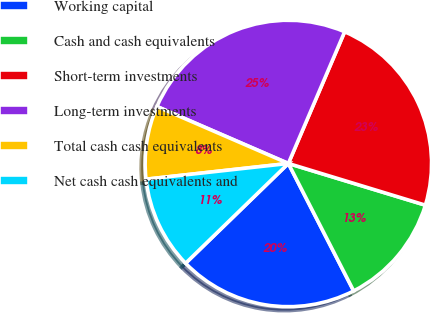<chart> <loc_0><loc_0><loc_500><loc_500><pie_chart><fcel>Working capital<fcel>Cash and cash equivalents<fcel>Short-term investments<fcel>Long-term investments<fcel>Total cash cash equivalents<fcel>Net cash cash equivalents and<nl><fcel>20.27%<fcel>12.76%<fcel>23.27%<fcel>24.92%<fcel>8.26%<fcel>10.51%<nl></chart> 